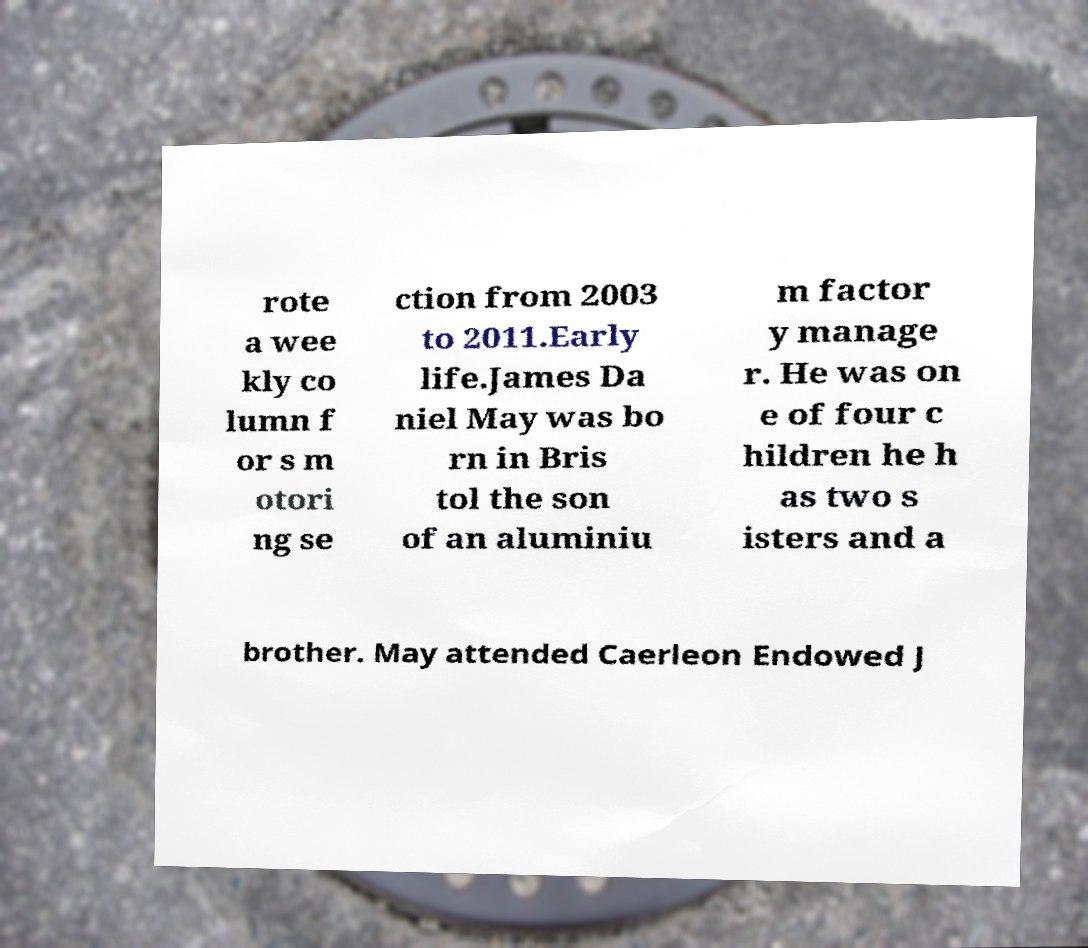Could you assist in decoding the text presented in this image and type it out clearly? rote a wee kly co lumn f or s m otori ng se ction from 2003 to 2011.Early life.James Da niel May was bo rn in Bris tol the son of an aluminiu m factor y manage r. He was on e of four c hildren he h as two s isters and a brother. May attended Caerleon Endowed J 